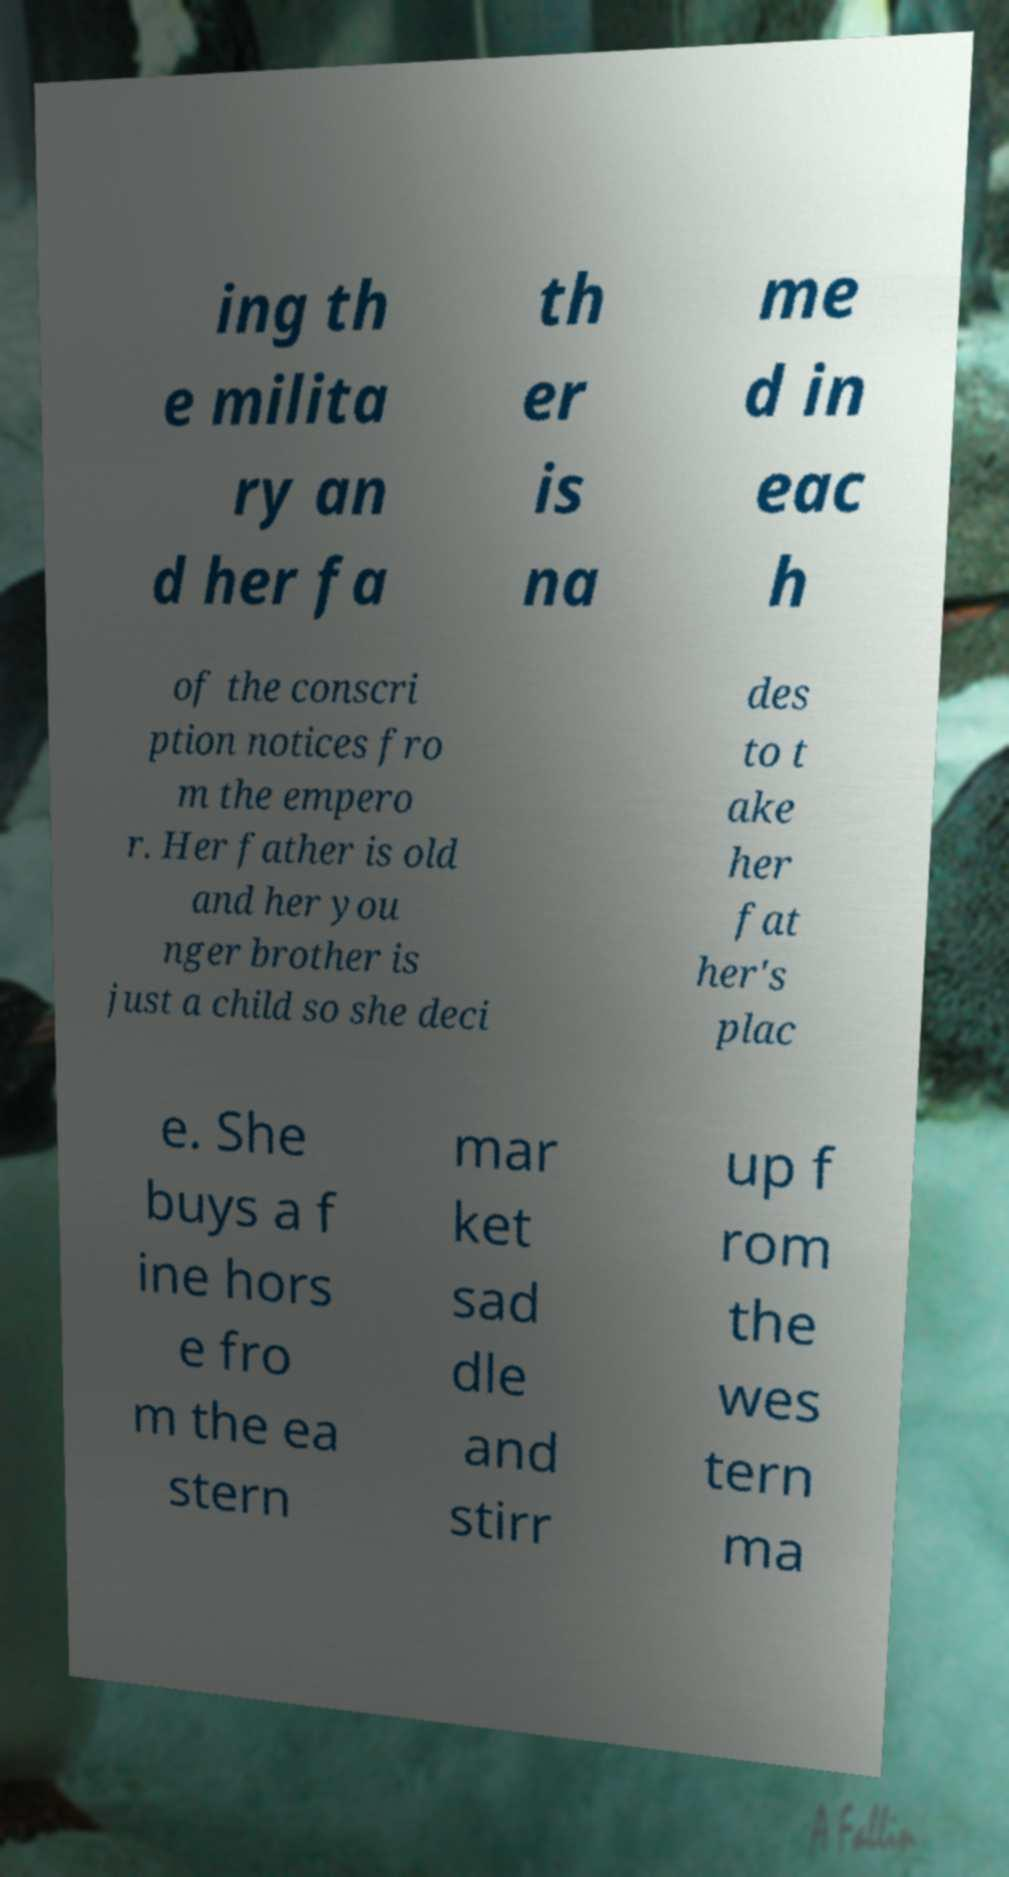Can you accurately transcribe the text from the provided image for me? ing th e milita ry an d her fa th er is na me d in eac h of the conscri ption notices fro m the empero r. Her father is old and her you nger brother is just a child so she deci des to t ake her fat her's plac e. She buys a f ine hors e fro m the ea stern mar ket sad dle and stirr up f rom the wes tern ma 